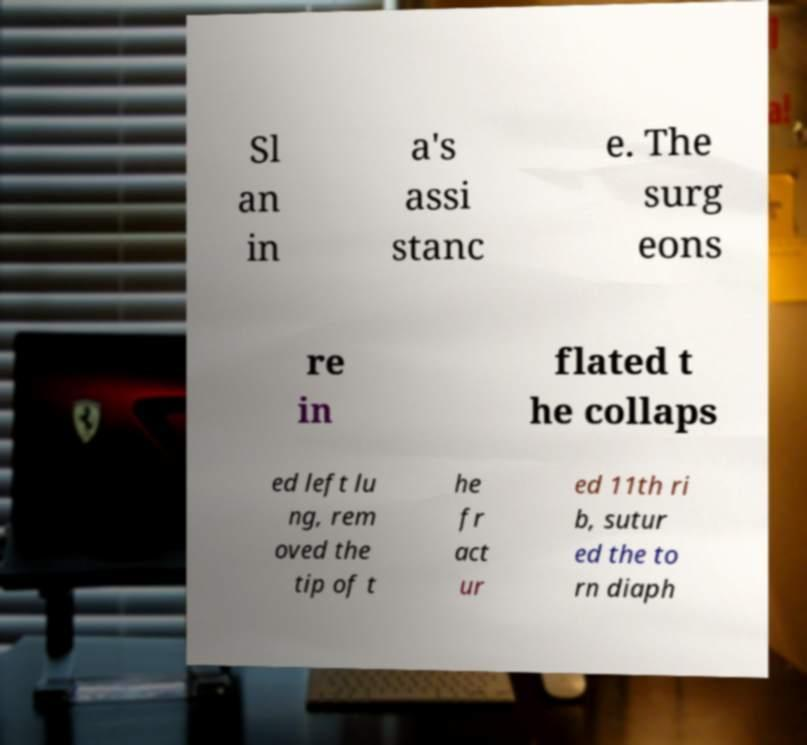For documentation purposes, I need the text within this image transcribed. Could you provide that? Sl an in a's assi stanc e. The surg eons re in flated t he collaps ed left lu ng, rem oved the tip of t he fr act ur ed 11th ri b, sutur ed the to rn diaph 